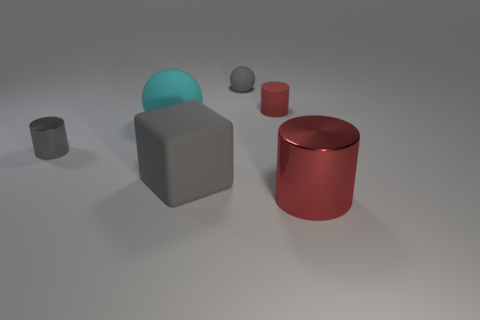The large cylinder has what color?
Offer a very short reply. Red. How many other things are there of the same size as the gray matte cube?
Ensure brevity in your answer.  2. There is a sphere in front of the tiny object that is on the right side of the tiny gray rubber thing; what is its material?
Your response must be concise. Rubber. Does the gray ball have the same size as the red thing behind the cyan sphere?
Provide a succinct answer. Yes. Is there a small rubber object of the same color as the large shiny thing?
Provide a short and direct response. Yes. How many large things are metal objects or cyan objects?
Offer a very short reply. 2. How many tiny objects are there?
Your answer should be very brief. 3. There is a ball on the left side of the tiny gray matte thing; what is it made of?
Give a very brief answer. Rubber. There is a big red metallic thing; are there any gray rubber cubes left of it?
Provide a short and direct response. Yes. Is the cyan thing the same size as the cube?
Ensure brevity in your answer.  Yes. 